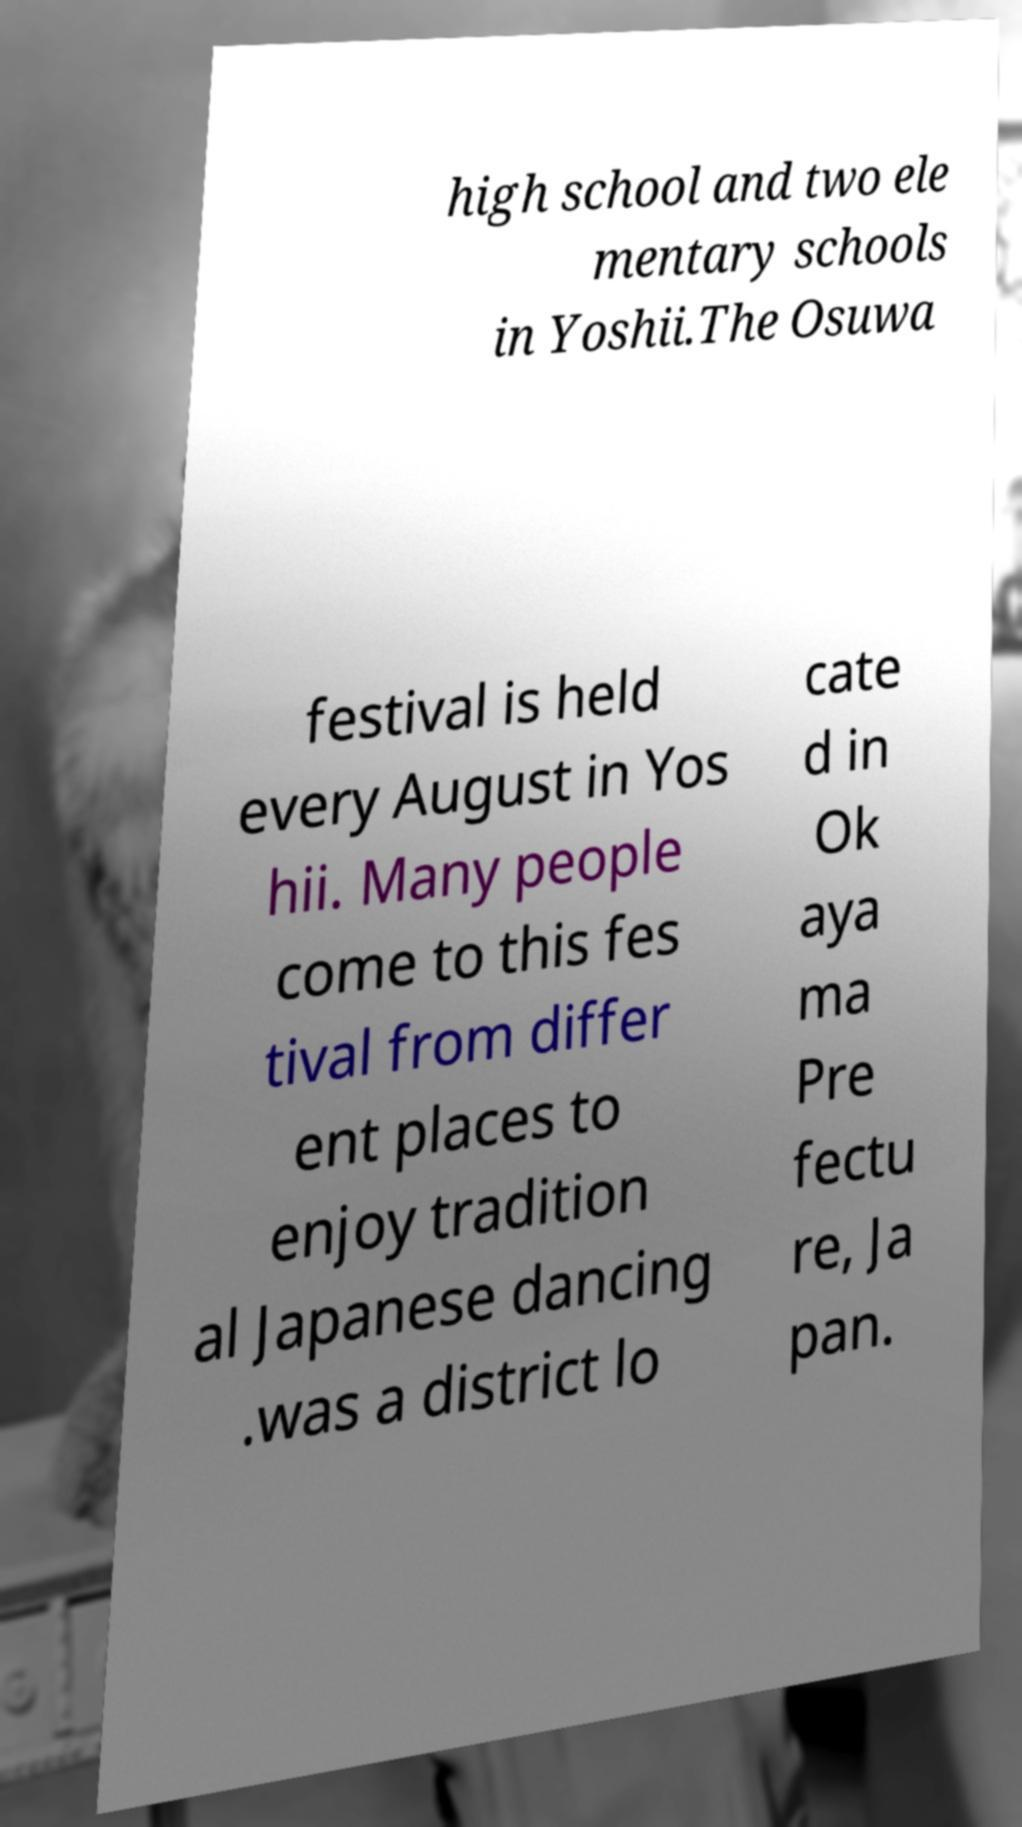Please read and relay the text visible in this image. What does it say? high school and two ele mentary schools in Yoshii.The Osuwa festival is held every August in Yos hii. Many people come to this fes tival from differ ent places to enjoy tradition al Japanese dancing .was a district lo cate d in Ok aya ma Pre fectu re, Ja pan. 